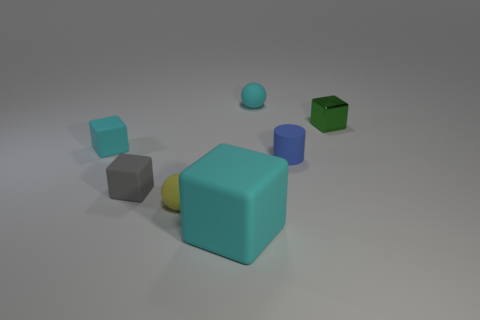Can you tell me about the different materials the objects may be made of in this image? Certainly! The objects in the image appear to have different textures suggesting various materials. The cyan cube has a matte finish that resembles rubber, the green and blue cubes look like they could be plastic due to their shininess, and the spheres have a smooth texture that might indicate a metallic or ceramic material. 